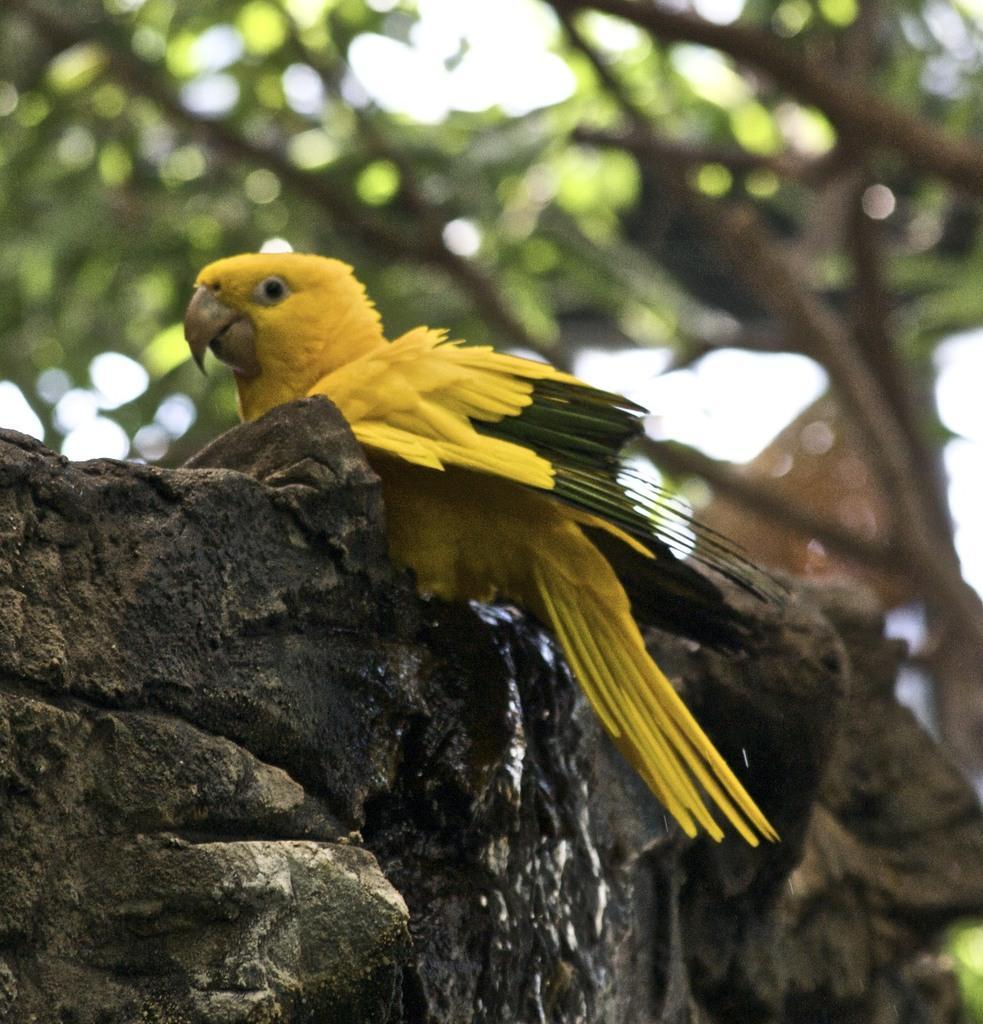Please provide a concise description of this image. In this picture we can see a bird on the wall, in the background we can see few trees. 